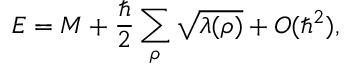<formula> <loc_0><loc_0><loc_500><loc_500>E = M + { \frac { } { 2 } } \sum _ { \rho } \sqrt { \lambda ( \rho ) } + O ( \hbar { ^ } { 2 } ) ,</formula> 